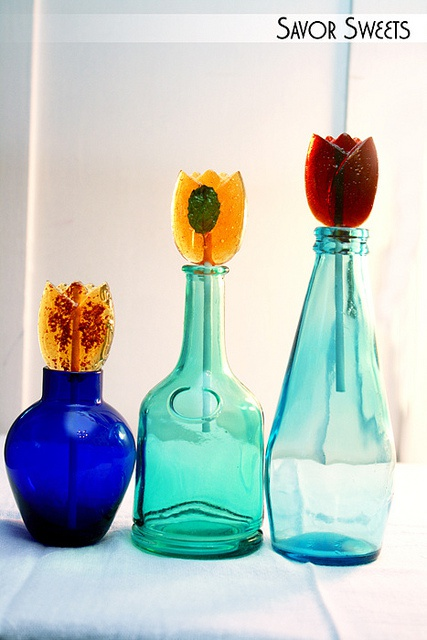Describe the objects in this image and their specific colors. I can see dining table in darkgray, lightgray, lightblue, and black tones, vase in darkgray, ivory, turquoise, and teal tones, vase in darkgray, aquamarine, turquoise, and teal tones, and vase in darkgray, darkblue, black, navy, and blue tones in this image. 